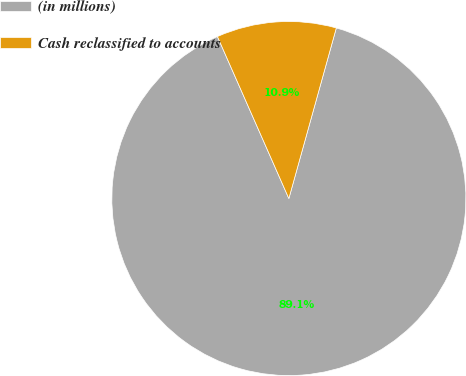Convert chart. <chart><loc_0><loc_0><loc_500><loc_500><pie_chart><fcel>(in millions)<fcel>Cash reclassified to accounts<nl><fcel>89.07%<fcel>10.93%<nl></chart> 